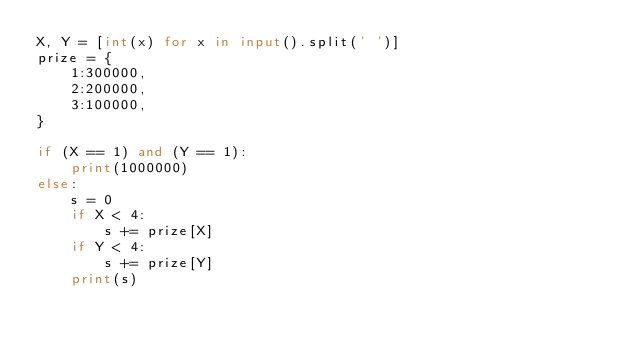<code> <loc_0><loc_0><loc_500><loc_500><_Python_>X, Y = [int(x) for x in input().split(' ')]
prize = {
    1:300000,
    2:200000,
    3:100000,
}

if (X == 1) and (Y == 1):
    print(1000000)
else:
    s = 0
    if X < 4:
        s += prize[X]
    if Y < 4:
        s += prize[Y]
    print(s)</code> 